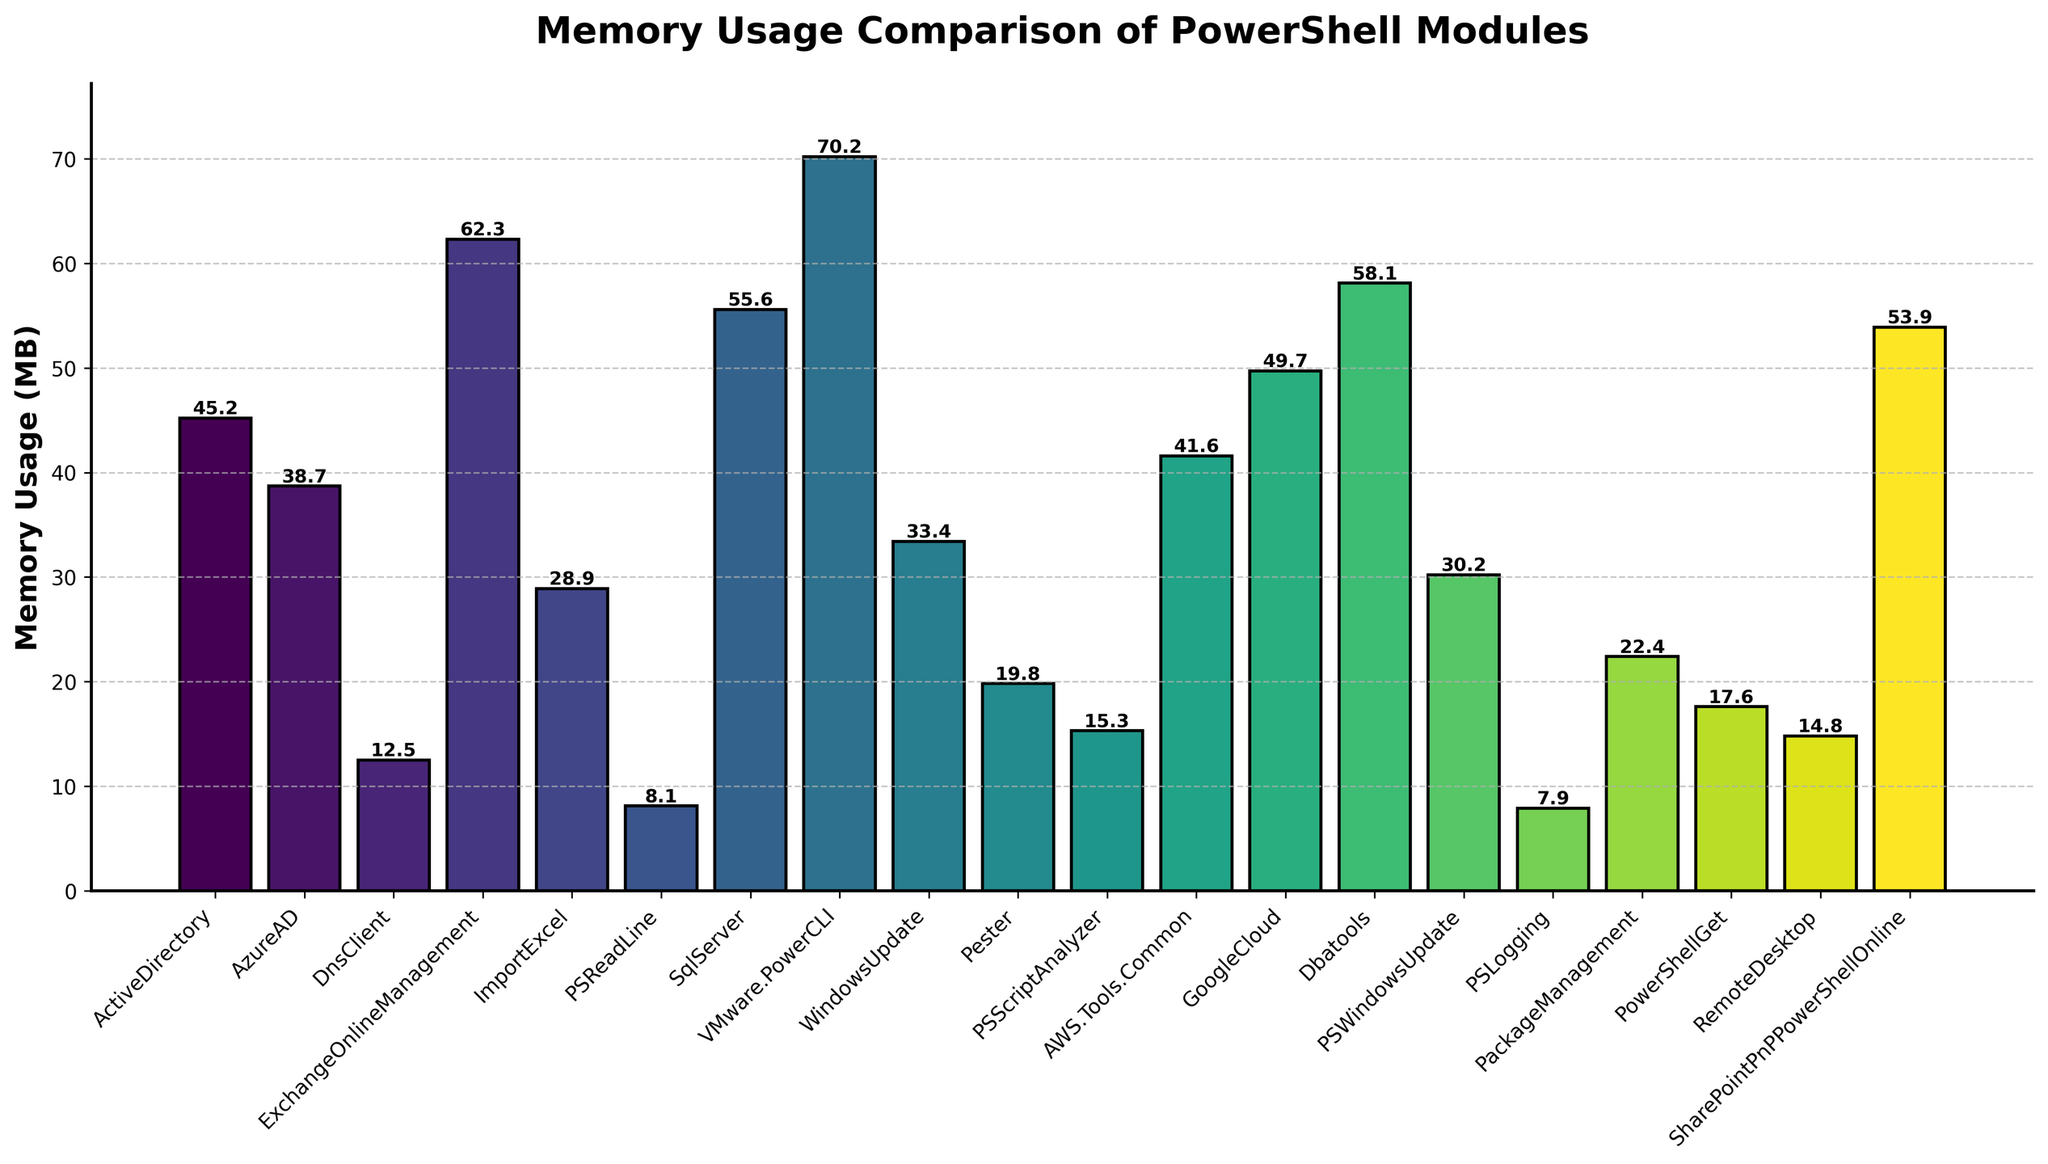What's the module with the highest memory usage, and how much is it? The module with the highest memory usage is indicated by the tallest bar on the chart. This bar corresponds to VMware.PowerCLI with a height of 70.2 MB.
Answer: VMware.PowerCLI, 70.2 MB What’s the difference in memory usage between the ExchangeOnlineManagement and PSReadLine modules? Identify the heights of the bars for ExchangeOnlineManagement (62.3 MB) and PSReadLine (8.1 MB). Subtract the lower value from the higher value. 62.3 - 8.1 = 54.2 MB.
Answer: 54.2 MB Which modules have a memory usage below 20 MB? Look for the bars that are shorter than the 20 MB mark on the y-axis. These bars correspond to the PSReadLine, PSLogging, PSScriptAnalyzer, RemoteDesktop, and PowerShellGet modules.
Answer: PSReadLine, PSLogging, PSScriptAnalyzer, RemoteDesktop, PowerShellGet What’s the average memory usage of the modules? Add the memory usages of all modules and then divide by the number of modules. (45.2 + 38.7 + 12.5 + 62.3 + 28.9 + 8.1 + 55.6 + 70.2 + 33.4 + 19.8 + 15.3 + 41.6 + 49.7 + 58.1 + 30.2 + 7.9 + 22.4 + 17.6 + 14.8 + 53.9) / 20 ≈ 32.88 MB.
Answer: 32.88 MB Is the memory usage of the Dbatools module more than double that of the PSLogging module? Compare the memory usages of Dbatools (58.1 MB) and PSLogging (7.9 MB). Check if 58.1 is more than double of 7.9, which is 15.8. 58.1 > 15.8, so yes.
Answer: Yes How many modules consume more than 50 MB of memory? Count the bars whose heights exceed the 50 MB mark on the y-axis. These correspond to ExchangeOnlineManagement, SqlServer, VMware.PowerCLI, GoogleCloud, Dbatools, and SharePointPnPPowerShellOnline, totaling six modules.
Answer: 6 What's the combined memory usage of the ActiveDirectory and AWS.Tools.Common modules? Sum the memory usages of ActiveDirectory (45.2 MB) and AWS.Tools.Common (41.6 MB). 45.2 + 41.6 = 86.8 MB.
Answer: 86.8 MB Which module has the memory usage closest to the median value? To find the median, order the memory usages and find the middle value, which for 20 numbers is the average of the 10th and 11th values. (17.6 + 19.8) / 2 = 18.7 MB. The closest module to this value is Pester with 19.8 MB.
Answer: Pester What visual attribute indicates the memory usage ranking among the modules? The height of the bars visually indicates the memory usage ranking. Taller bars represent higher memory usage, while shorter bars represent lower memory usage.
Answer: Height of the bars 